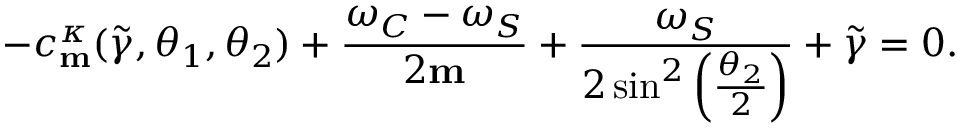Convert formula to latex. <formula><loc_0><loc_0><loc_500><loc_500>- c _ { m } ^ { \kappa } ( \widetilde { \gamma } , \theta _ { 1 } , \theta _ { 2 } ) + \frac { \omega _ { C } - \omega _ { S } } { 2 m } + \frac { \omega _ { S } } { 2 \sin ^ { 2 } \left ( \frac { \theta _ { 2 } } { 2 } \right ) } + \widetilde { \gamma } = 0 .</formula> 